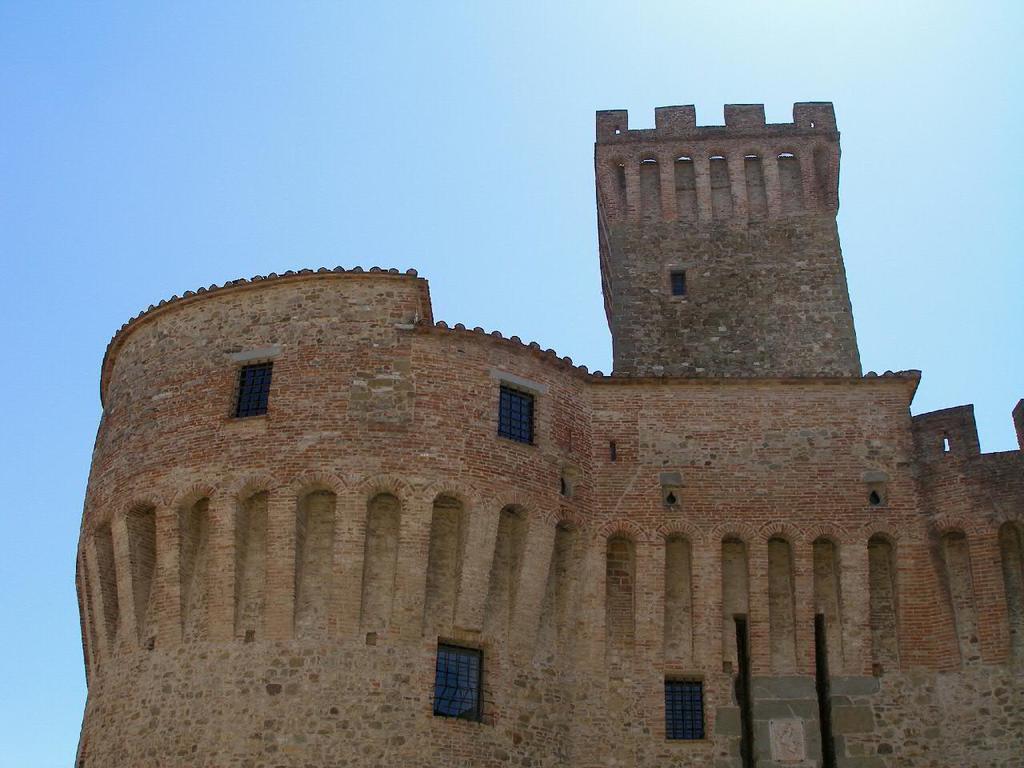How would you summarize this image in a sentence or two? In this picture we can see a fort. 